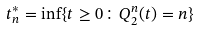<formula> <loc_0><loc_0><loc_500><loc_500>t _ { n } ^ { * } = \inf \{ t \geq 0 \colon Q ^ { n } _ { 2 } ( t ) = n \}</formula> 